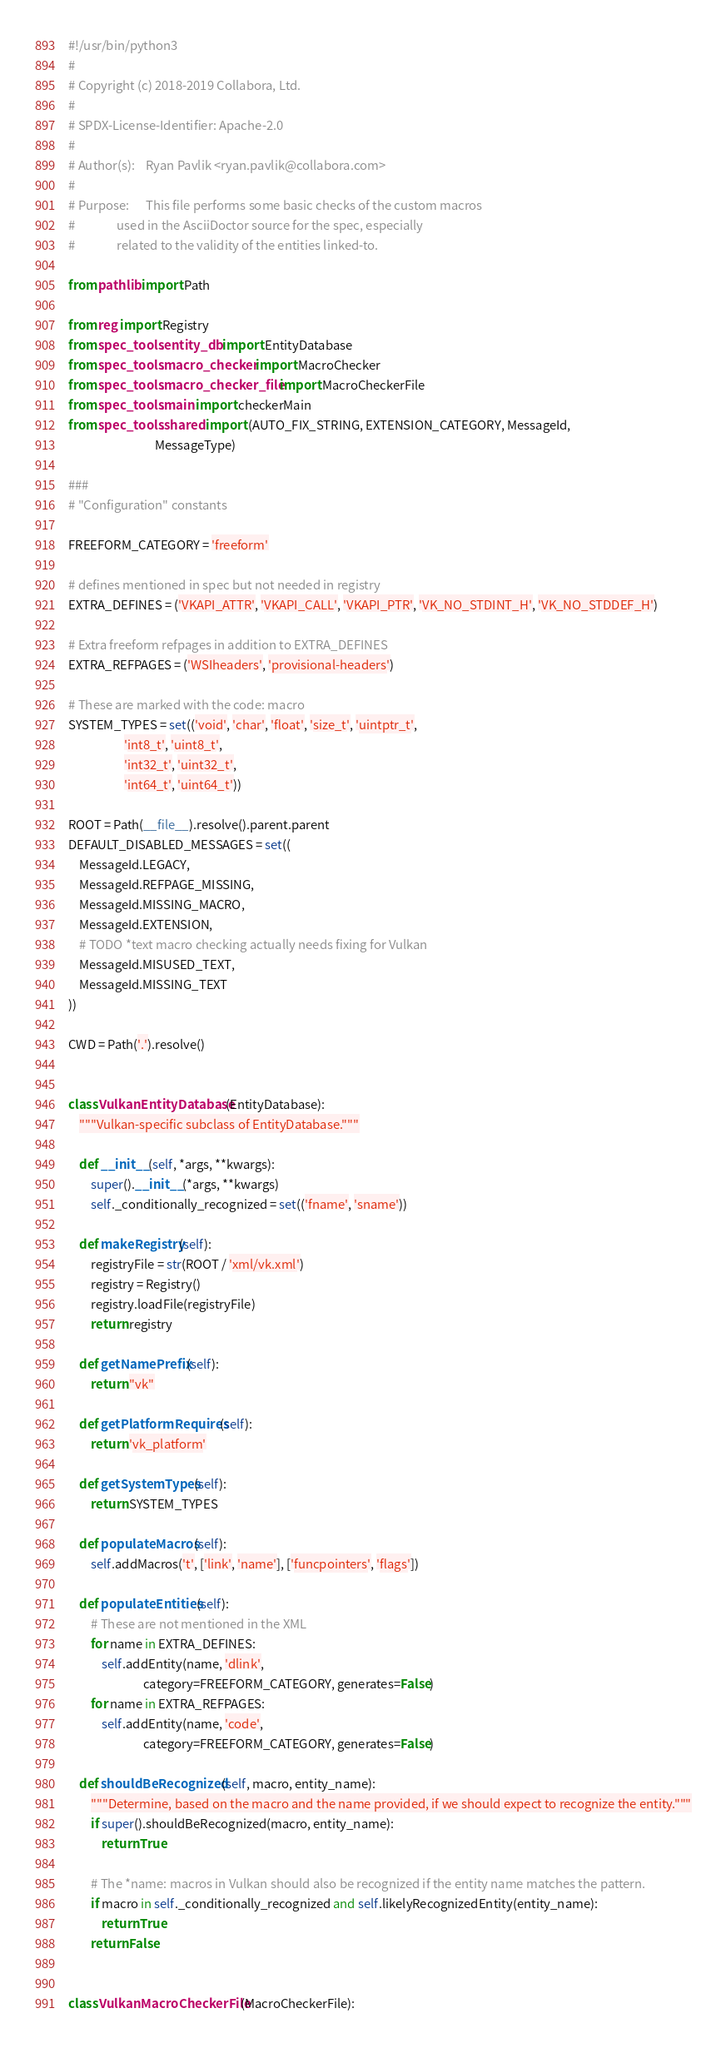<code> <loc_0><loc_0><loc_500><loc_500><_Python_>#!/usr/bin/python3
#
# Copyright (c) 2018-2019 Collabora, Ltd.
#
# SPDX-License-Identifier: Apache-2.0
#
# Author(s):    Ryan Pavlik <ryan.pavlik@collabora.com>
#
# Purpose:      This file performs some basic checks of the custom macros
#               used in the AsciiDoctor source for the spec, especially
#               related to the validity of the entities linked-to.

from pathlib import Path

from reg import Registry
from spec_tools.entity_db import EntityDatabase
from spec_tools.macro_checker import MacroChecker
from spec_tools.macro_checker_file import MacroCheckerFile
from spec_tools.main import checkerMain
from spec_tools.shared import (AUTO_FIX_STRING, EXTENSION_CATEGORY, MessageId,
                               MessageType)

###
# "Configuration" constants

FREEFORM_CATEGORY = 'freeform'

# defines mentioned in spec but not needed in registry
EXTRA_DEFINES = ('VKAPI_ATTR', 'VKAPI_CALL', 'VKAPI_PTR', 'VK_NO_STDINT_H', 'VK_NO_STDDEF_H')

# Extra freeform refpages in addition to EXTRA_DEFINES
EXTRA_REFPAGES = ('WSIheaders', 'provisional-headers')

# These are marked with the code: macro
SYSTEM_TYPES = set(('void', 'char', 'float', 'size_t', 'uintptr_t',
                    'int8_t', 'uint8_t',
                    'int32_t', 'uint32_t',
                    'int64_t', 'uint64_t'))

ROOT = Path(__file__).resolve().parent.parent
DEFAULT_DISABLED_MESSAGES = set((
    MessageId.LEGACY,
    MessageId.REFPAGE_MISSING,
    MessageId.MISSING_MACRO,
    MessageId.EXTENSION,
    # TODO *text macro checking actually needs fixing for Vulkan
    MessageId.MISUSED_TEXT,
    MessageId.MISSING_TEXT
))

CWD = Path('.').resolve()


class VulkanEntityDatabase(EntityDatabase):
    """Vulkan-specific subclass of EntityDatabase."""

    def __init__(self, *args, **kwargs):
        super().__init__(*args, **kwargs)
        self._conditionally_recognized = set(('fname', 'sname'))

    def makeRegistry(self):
        registryFile = str(ROOT / 'xml/vk.xml')
        registry = Registry()
        registry.loadFile(registryFile)
        return registry

    def getNamePrefix(self):
        return "vk"

    def getPlatformRequires(self):
        return 'vk_platform'

    def getSystemTypes(self):
        return SYSTEM_TYPES

    def populateMacros(self):
        self.addMacros('t', ['link', 'name'], ['funcpointers', 'flags'])

    def populateEntities(self):
        # These are not mentioned in the XML
        for name in EXTRA_DEFINES:
            self.addEntity(name, 'dlink',
                           category=FREEFORM_CATEGORY, generates=False)
        for name in EXTRA_REFPAGES:
            self.addEntity(name, 'code',
                           category=FREEFORM_CATEGORY, generates=False)

    def shouldBeRecognized(self, macro, entity_name):
        """Determine, based on the macro and the name provided, if we should expect to recognize the entity."""
        if super().shouldBeRecognized(macro, entity_name):
            return True

        # The *name: macros in Vulkan should also be recognized if the entity name matches the pattern.
        if macro in self._conditionally_recognized and self.likelyRecognizedEntity(entity_name):
            return True
        return False


class VulkanMacroCheckerFile(MacroCheckerFile):</code> 